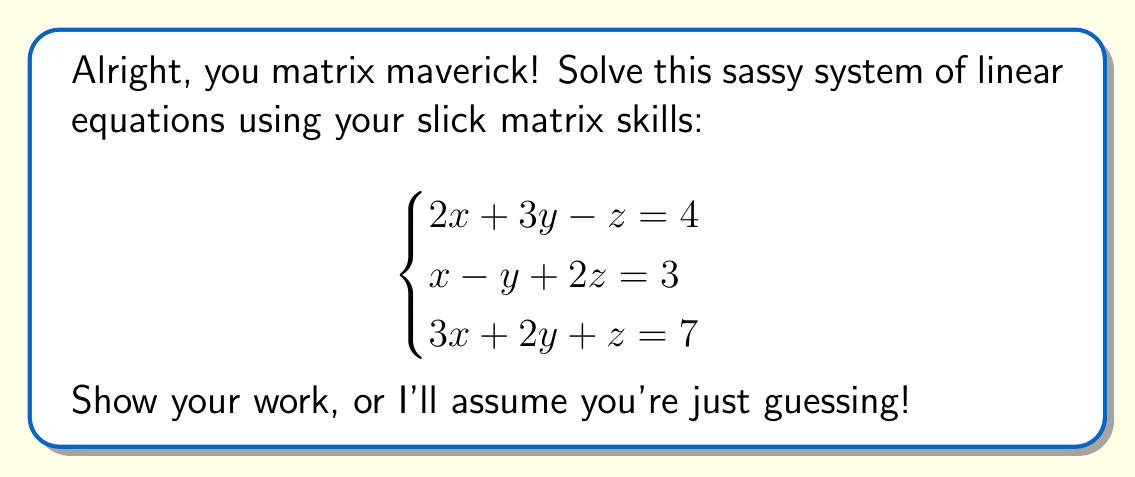Solve this math problem. Oh, you want a detailed explanation? Buckle up, buttercup!

Step 1: Set up the augmented matrix
$$\begin{bmatrix}
2 & 3 & -1 & | & 4 \\
1 & -1 & 2 & | & 3 \\
3 & 2 & 1 & | & 7
\end{bmatrix}$$

Step 2: Use Gaussian elimination to get an upper triangular matrix
Row 2 = Row 2 - $\frac{1}{2}$ Row 1
Row 3 = Row 3 - $\frac{3}{2}$ Row 1

$$\begin{bmatrix}
2 & 3 & -1 & | & 4 \\
0 & -\frac{5}{2} & \frac{5}{2} & | & 1 \\
0 & -\frac{5}{2} & \frac{5}{2} & | & 1
\end{bmatrix}$$

Step 3: Row 3 = Row 3 - Row 2

$$\begin{bmatrix}
2 & 3 & -1 & | & 4 \\
0 & -\frac{5}{2} & \frac{5}{2} & | & 1 \\
0 & 0 & 0 & | & 0
\end{bmatrix}$$

Step 4: Back-substitution
From Row 2: $-\frac{5}{2}y + \frac{5}{2}z = 1$
$y = z - \frac{2}{5}$

From Row 1: $2x + 3y - z = 4$
$2x + 3(z - \frac{2}{5}) - z = 4$
$2x + 3z - \frac{6}{5} - z = 4$
$2x + 2z = \frac{26}{5}$
$x + z = \frac{13}{5}$

Step 5: Express $x$ and $y$ in terms of $z$
$x = \frac{13}{5} - z$
$y = z - \frac{2}{5}$

The system has infinitely many solutions, with $z$ as a free variable.
Answer: $x = \frac{13}{5} - z$, $y = z - \frac{2}{5}$, $z$ is free 